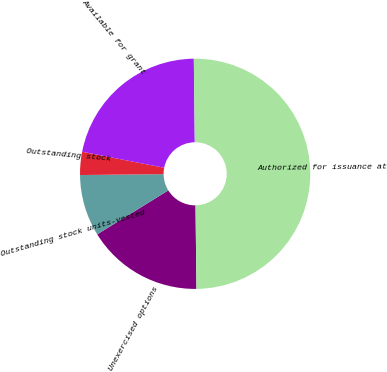<chart> <loc_0><loc_0><loc_500><loc_500><pie_chart><fcel>Unexercised options<fcel>Outstanding stock units-vested<fcel>Outstanding stock<fcel>Available for grant<fcel>Authorized for issuance at<nl><fcel>16.37%<fcel>8.64%<fcel>3.24%<fcel>21.75%<fcel>50.0%<nl></chart> 